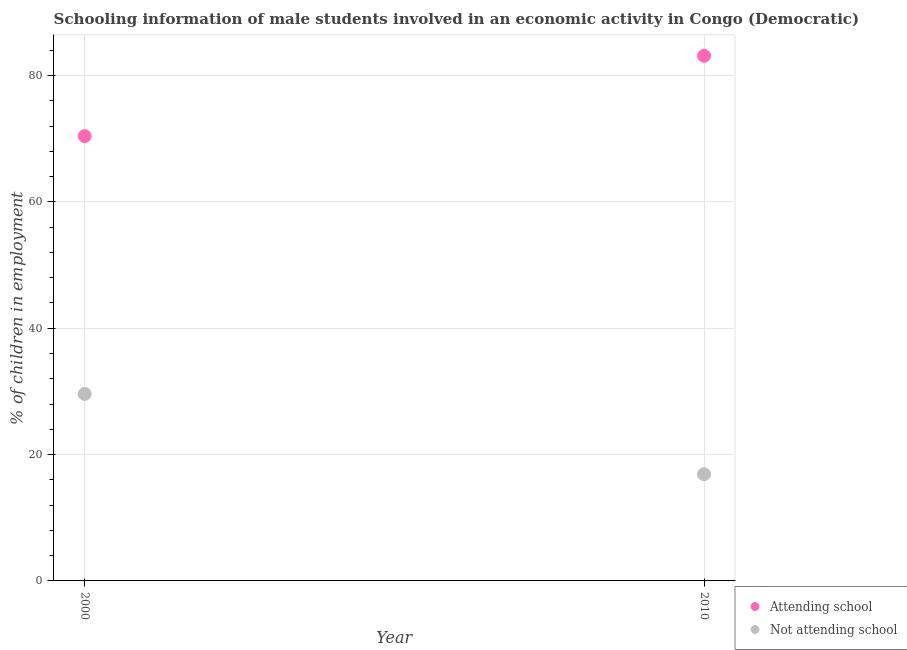What is the percentage of employed males who are not attending school in 2000?
Your response must be concise. 29.6. Across all years, what is the maximum percentage of employed males who are not attending school?
Offer a terse response. 29.6. Across all years, what is the minimum percentage of employed males who are attending school?
Your answer should be very brief. 70.4. In which year was the percentage of employed males who are not attending school minimum?
Provide a succinct answer. 2010. What is the total percentage of employed males who are attending school in the graph?
Ensure brevity in your answer.  153.51. What is the difference between the percentage of employed males who are not attending school in 2000 and that in 2010?
Give a very brief answer. 12.71. What is the difference between the percentage of employed males who are attending school in 2010 and the percentage of employed males who are not attending school in 2000?
Your answer should be very brief. 53.51. What is the average percentage of employed males who are not attending school per year?
Offer a terse response. 23.24. In the year 2000, what is the difference between the percentage of employed males who are attending school and percentage of employed males who are not attending school?
Offer a very short reply. 40.8. What is the ratio of the percentage of employed males who are not attending school in 2000 to that in 2010?
Provide a short and direct response. 1.75. Is the percentage of employed males who are attending school strictly greater than the percentage of employed males who are not attending school over the years?
Your response must be concise. Yes. Is the percentage of employed males who are attending school strictly less than the percentage of employed males who are not attending school over the years?
Keep it short and to the point. No. How many years are there in the graph?
Offer a terse response. 2. What is the difference between two consecutive major ticks on the Y-axis?
Offer a terse response. 20. Are the values on the major ticks of Y-axis written in scientific E-notation?
Provide a succinct answer. No. Does the graph contain any zero values?
Your response must be concise. No. Does the graph contain grids?
Provide a succinct answer. Yes. How many legend labels are there?
Make the answer very short. 2. What is the title of the graph?
Keep it short and to the point. Schooling information of male students involved in an economic activity in Congo (Democratic). What is the label or title of the X-axis?
Ensure brevity in your answer.  Year. What is the label or title of the Y-axis?
Your answer should be very brief. % of children in employment. What is the % of children in employment in Attending school in 2000?
Offer a very short reply. 70.4. What is the % of children in employment of Not attending school in 2000?
Provide a short and direct response. 29.6. What is the % of children in employment of Attending school in 2010?
Offer a terse response. 83.11. What is the % of children in employment of Not attending school in 2010?
Give a very brief answer. 16.89. Across all years, what is the maximum % of children in employment of Attending school?
Offer a very short reply. 83.11. Across all years, what is the maximum % of children in employment in Not attending school?
Provide a short and direct response. 29.6. Across all years, what is the minimum % of children in employment of Attending school?
Offer a terse response. 70.4. Across all years, what is the minimum % of children in employment in Not attending school?
Provide a succinct answer. 16.89. What is the total % of children in employment in Attending school in the graph?
Your answer should be compact. 153.51. What is the total % of children in employment of Not attending school in the graph?
Give a very brief answer. 46.49. What is the difference between the % of children in employment of Attending school in 2000 and that in 2010?
Give a very brief answer. -12.71. What is the difference between the % of children in employment of Not attending school in 2000 and that in 2010?
Your answer should be very brief. 12.71. What is the difference between the % of children in employment in Attending school in 2000 and the % of children in employment in Not attending school in 2010?
Provide a short and direct response. 53.51. What is the average % of children in employment of Attending school per year?
Make the answer very short. 76.76. What is the average % of children in employment in Not attending school per year?
Give a very brief answer. 23.24. In the year 2000, what is the difference between the % of children in employment of Attending school and % of children in employment of Not attending school?
Ensure brevity in your answer.  40.8. In the year 2010, what is the difference between the % of children in employment of Attending school and % of children in employment of Not attending school?
Offer a very short reply. 66.23. What is the ratio of the % of children in employment of Attending school in 2000 to that in 2010?
Provide a succinct answer. 0.85. What is the ratio of the % of children in employment in Not attending school in 2000 to that in 2010?
Your answer should be very brief. 1.75. What is the difference between the highest and the second highest % of children in employment in Attending school?
Offer a very short reply. 12.71. What is the difference between the highest and the second highest % of children in employment of Not attending school?
Give a very brief answer. 12.71. What is the difference between the highest and the lowest % of children in employment in Attending school?
Provide a succinct answer. 12.71. What is the difference between the highest and the lowest % of children in employment in Not attending school?
Your answer should be compact. 12.71. 